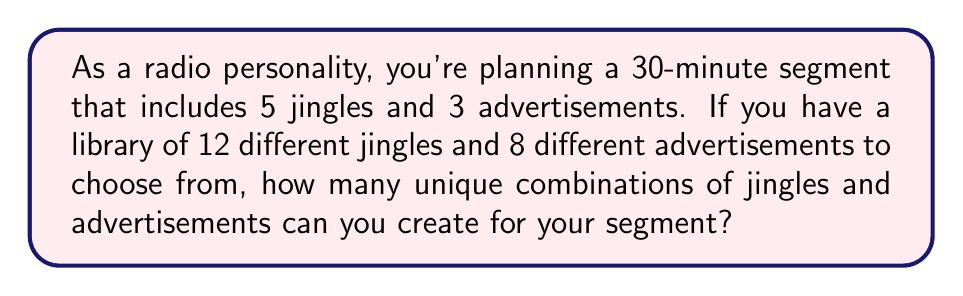Give your solution to this math problem. Let's break this down step-by-step:

1) First, we need to choose 5 jingles from the 12 available. This is a combination problem, as the order doesn't matter. We use the combination formula:

   $$C(12,5) = \frac{12!}{5!(12-5)!} = \frac{12!}{5!7!}$$

2) Next, we need to choose 3 advertisements from the 8 available. Again, this is a combination:

   $$C(8,3) = \frac{8!}{3!(8-3)!} = \frac{8!}{3!5!}$$

3) By the multiplication principle, the total number of ways to choose both jingles and advertisements is the product of these two combinations:

   $$\text{Total combinations} = C(12,5) \times C(8,3)$$

4) Let's calculate each combination:

   $$C(12,5) = \frac{12!}{5!7!} = 792$$
   $$C(8,3) = \frac{8!}{3!5!} = 56$$

5) Now, we multiply these results:

   $$792 \times 56 = 44,352$$

Therefore, there are 44,352 unique combinations of jingles and advertisements for the segment.
Answer: 44,352 